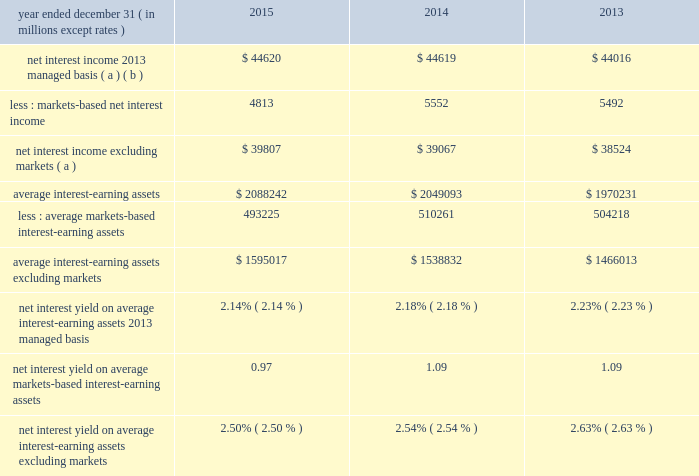Management 2019s discussion and analysis 82 jpmorgan chase & co./2015 annual report net interest income excluding markets-based activities ( formerly core net interest income ) in addition to reviewing net interest income on a managed basis , management also reviews net interest income excluding cib 2019s markets-based activities to assess the performance of the firm 2019s lending , investing ( including asset-liability management ) and deposit-raising activities .
The data presented below are non-gaap financial measures due to the exclusion of cib 2019s markets-based net interest income and related assets .
Management believes this exclusion provides investors and analysts with another measure by which to analyze the non-markets-related business trends of the firm and provides a comparable measure to other financial institutions that are primarily focused on lending , investing and deposit-raising activities .
Net interest income excluding cib markets-based activities data year ended december 31 , ( in millions , except rates ) 2015 2014 2013 net interest income 2013 managed basis ( a ) ( b ) $ 44620 $ 44619 $ 44016 less : markets-based net interest income 4813 5552 5492 net interest income excluding markets ( a ) $ 39807 $ 39067 $ 38524 average interest-earning assets $ 2088242 $ 2049093 $ 1970231 less : average markets- based interest-earning assets 493225 510261 504218 average interest- earning assets excluding markets $ 1595017 $ 1538832 $ 1466013 net interest yield on average interest-earning assets 2013 managed basis 2.14% ( 2.14 % ) 2.18% ( 2.18 % ) 2.23% ( 2.23 % ) net interest yield on average markets-based interest-earning assets 0.97 1.09 1.09 net interest yield on average interest-earning assets excluding markets 2.50% ( 2.50 % ) 2.54% ( 2.54 % ) 2.63% ( 2.63 % ) ( a ) interest includes the effect of related hedging derivatives .
Taxable-equivalent amounts are used where applicable .
( b ) for a reconciliation of net interest income on a reported and managed basis , see reconciliation from the firm 2019s reported u.s .
Gaap results to managed basis on page 80 .
2015 compared with 2014 net interest income excluding cib 2019s markets-based activities increased by $ 740 million in 2015 to $ 39.8 billion , and average interest-earning assets increased by $ 56.2 billion to $ 1.6 trillion .
The increase in net interest income in 2015 predominantly reflected higher average loan balances and lower interest expense on deposits .
The increase was partially offset by lower loan yields and lower investment securities net interest income .
The increase in average interest-earning assets largely reflected the impact of higher average deposits with banks .
These changes in net interest income and interest-earning assets resulted in the net interest yield decreasing by 4 basis points to 2.50% ( 2.50 % ) for 2014 compared with 2013 net interest income excluding cib 2019s markets-based activities increased by $ 543 million in 2014 to $ 39.1 billion , and average interest-earning assets increased by $ 72.8 billion to $ 1.5 trillion .
The increase in net interest income in 2014 predominantly reflected higher yields on investment securities , the impact of lower interest expense , and higher average loan balances .
The increase was partially offset by lower yields on loans due to the run-off of higher-yielding loans and new originations of lower-yielding loans .
The increase in average interest-earning assets largely reflected the impact of higher average balance of deposits with banks .
These changes in net interest income and interest- earning assets resulted in the net interest yield decreasing by 9 basis points to 2.54% ( 2.54 % ) for 2014. .
Management 2019s discussion and analysis 82 jpmorgan chase & co./2015 annual report net interest income excluding markets-based activities ( formerly core net interest income ) in addition to reviewing net interest income on a managed basis , management also reviews net interest income excluding cib 2019s markets-based activities to assess the performance of the firm 2019s lending , investing ( including asset-liability management ) and deposit-raising activities .
The data presented below are non-gaap financial measures due to the exclusion of cib 2019s markets-based net interest income and related assets .
Management believes this exclusion provides investors and analysts with another measure by which to analyze the non-markets-related business trends of the firm and provides a comparable measure to other financial institutions that are primarily focused on lending , investing and deposit-raising activities .
Net interest income excluding cib markets-based activities data year ended december 31 , ( in millions , except rates ) 2015 2014 2013 net interest income 2013 managed basis ( a ) ( b ) $ 44620 $ 44619 $ 44016 less : markets-based net interest income 4813 5552 5492 net interest income excluding markets ( a ) $ 39807 $ 39067 $ 38524 average interest-earning assets $ 2088242 $ 2049093 $ 1970231 less : average markets- based interest-earning assets 493225 510261 504218 average interest- earning assets excluding markets $ 1595017 $ 1538832 $ 1466013 net interest yield on average interest-earning assets 2013 managed basis 2.14% ( 2.14 % ) 2.18% ( 2.18 % ) 2.23% ( 2.23 % ) net interest yield on average markets-based interest-earning assets 0.97 1.09 1.09 net interest yield on average interest-earning assets excluding markets 2.50% ( 2.50 % ) 2.54% ( 2.54 % ) 2.63% ( 2.63 % ) ( a ) interest includes the effect of related hedging derivatives .
Taxable-equivalent amounts are used where applicable .
( b ) for a reconciliation of net interest income on a reported and managed basis , see reconciliation from the firm 2019s reported u.s .
Gaap results to managed basis on page 80 .
2015 compared with 2014 net interest income excluding cib 2019s markets-based activities increased by $ 740 million in 2015 to $ 39.8 billion , and average interest-earning assets increased by $ 56.2 billion to $ 1.6 trillion .
The increase in net interest income in 2015 predominantly reflected higher average loan balances and lower interest expense on deposits .
The increase was partially offset by lower loan yields and lower investment securities net interest income .
The increase in average interest-earning assets largely reflected the impact of higher average deposits with banks .
These changes in net interest income and interest-earning assets resulted in the net interest yield decreasing by 4 basis points to 2.50% ( 2.50 % ) for 2014 compared with 2013 net interest income excluding cib 2019s markets-based activities increased by $ 543 million in 2014 to $ 39.1 billion , and average interest-earning assets increased by $ 72.8 billion to $ 1.5 trillion .
The increase in net interest income in 2014 predominantly reflected higher yields on investment securities , the impact of lower interest expense , and higher average loan balances .
The increase was partially offset by lower yields on loans due to the run-off of higher-yielding loans and new originations of lower-yielding loans .
The increase in average interest-earning assets largely reflected the impact of higher average balance of deposits with banks .
These changes in net interest income and interest- earning assets resulted in the net interest yield decreasing by 9 basis points to 2.54% ( 2.54 % ) for 2014. .
In 2015 what was the percentage change in the net interest income excluding cib 2019s markets-based activities from 2014? 
Computations: (740 / 39.8)
Answer: 18.59296. 